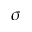Convert formula to latex. <formula><loc_0><loc_0><loc_500><loc_500>\sigma</formula> 